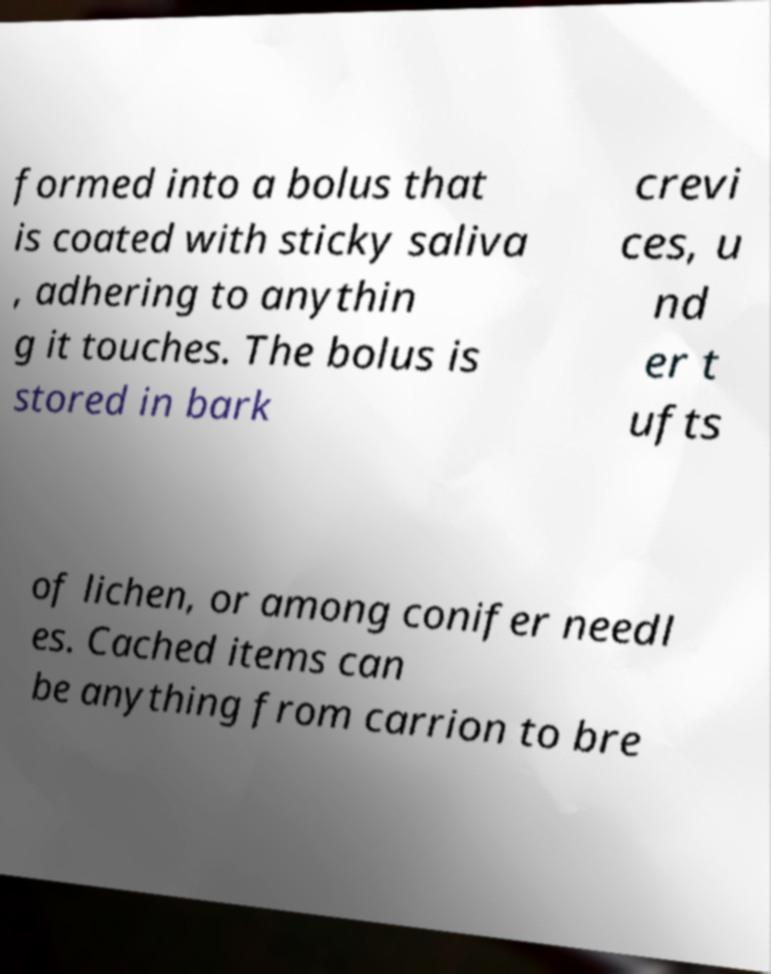I need the written content from this picture converted into text. Can you do that? formed into a bolus that is coated with sticky saliva , adhering to anythin g it touches. The bolus is stored in bark crevi ces, u nd er t ufts of lichen, or among conifer needl es. Cached items can be anything from carrion to bre 